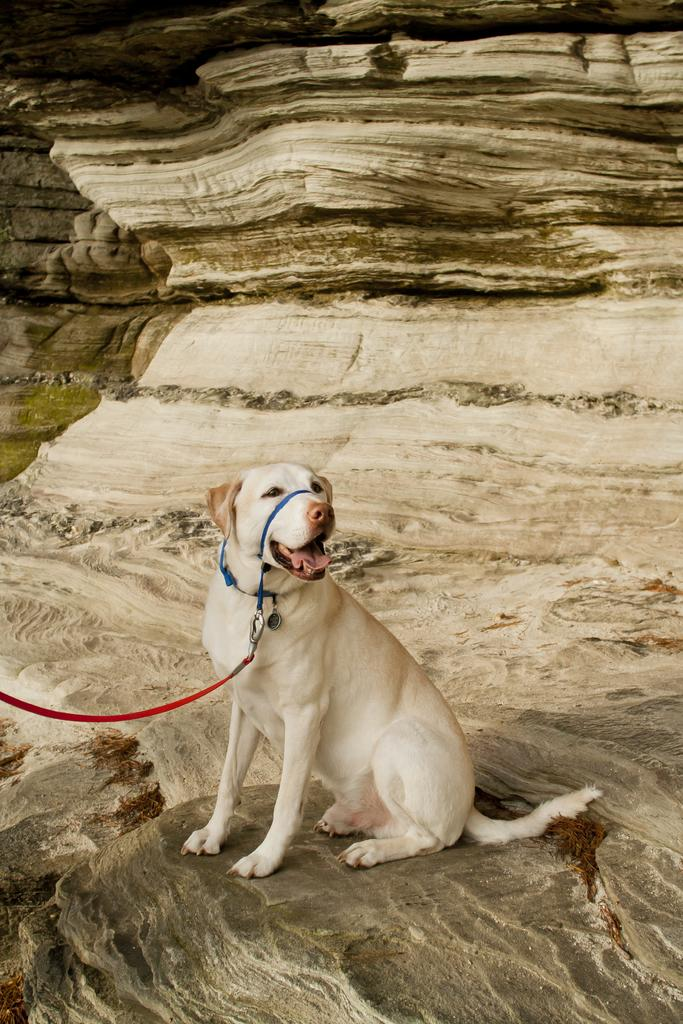What type of animal is in the picture? There is a dog in the picture. Is the dog attached to anything in the picture? Yes, the dog has a rope tied to it. What can be seen in the background of the picture? There is a stone visible in the background of the picture. How many lawyers are present in the picture? There are no lawyers present in the picture; it features a dog with a rope tied to it and a stone in the background. What type of trees can be seen in the picture? There are no trees present in the picture; it features a dog with a rope tied to it and a stone in the background. 